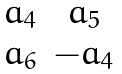Convert formula to latex. <formula><loc_0><loc_0><loc_500><loc_500>\begin{matrix} a _ { 4 } & a _ { 5 } \\ a _ { 6 } & - a _ { 4 } \end{matrix}</formula> 